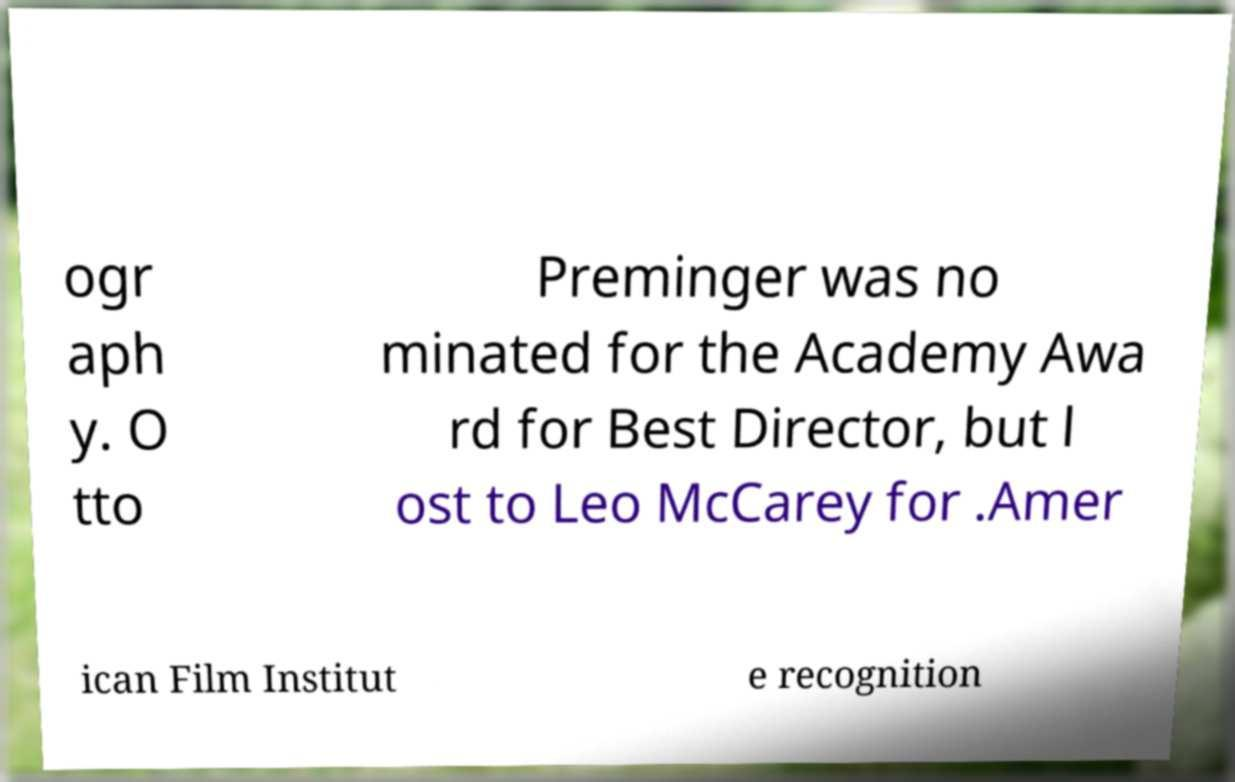There's text embedded in this image that I need extracted. Can you transcribe it verbatim? ogr aph y. O tto Preminger was no minated for the Academy Awa rd for Best Director, but l ost to Leo McCarey for .Amer ican Film Institut e recognition 